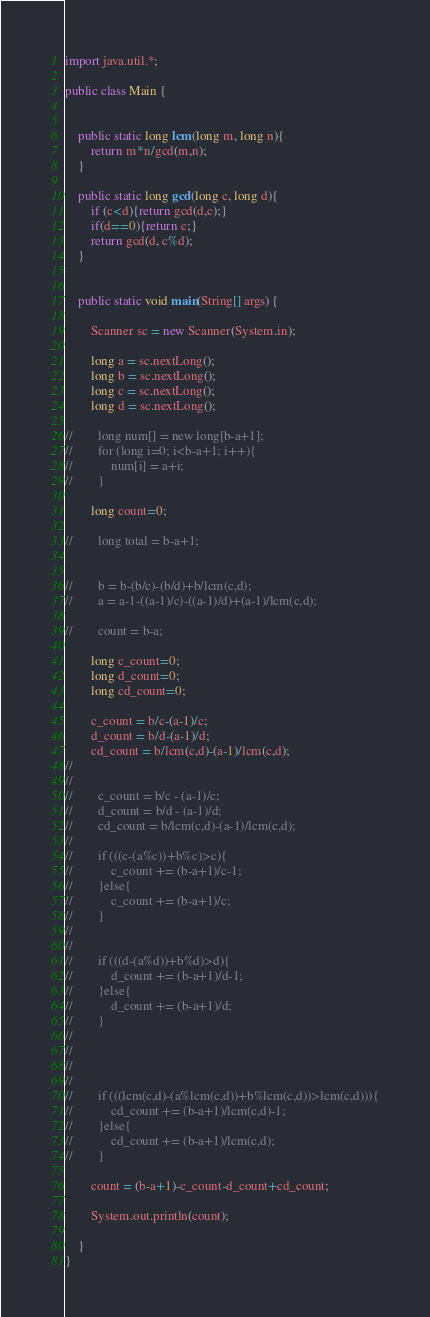<code> <loc_0><loc_0><loc_500><loc_500><_Java_>import java.util.*;

public class Main {


    public static long lcm(long m, long n){
        return m*n/gcd(m,n);
    }

    public static long gcd(long c, long d){
        if (c<d){return gcd(d,c);}
        if(d==0){return c;}
        return gcd(d, c%d);
    }


    public static void main(String[] args) {

        Scanner sc = new Scanner(System.in);

        long a = sc.nextLong();
        long b = sc.nextLong();
        long c = sc.nextLong();
        long d = sc.nextLong();

//        long num[] = new long[b-a+1];
//        for (long i=0; i<b-a+1; i++){
//            num[i] = a+i;
//        }

        long count=0;

//        long total = b-a+1;


//        b = b-(b/c)-(b/d)+b/lcm(c,d);
//        a = a-1-((a-1)/c)-((a-1)/d)+(a-1)/lcm(c,d);

//        count = b-a;

        long c_count=0;
        long d_count=0;
        long cd_count=0;

        c_count = b/c-(a-1)/c;
        d_count = b/d-(a-1)/d;
        cd_count = b/lcm(c,d)-(a-1)/lcm(c,d);
//
//
//        c_count = b/c - (a-1)/c;
//        d_count = b/d - (a-1)/d;
//        cd_count = b/lcm(c,d)-(a-1)/lcm(c,d);
//
//        if (((c-(a%c))+b%c)>c){
//            c_count += (b-a+1)/c-1;
//        }else{
//            c_count += (b-a+1)/c;
//        }
//
//
//        if (((d-(a%d))+b%d)>d){
//            d_count += (b-a+1)/d-1;
//        }else{
//            d_count += (b-a+1)/d;
//        }
//
//
//
//
//        if (((lcm(c,d)-(a%lcm(c,d))+b%lcm(c,d))>lcm(c,d))){
//            cd_count += (b-a+1)/lcm(c,d)-1;
//        }else{
//            cd_count += (b-a+1)/lcm(c,d);
//        }

        count = (b-a+1)-c_count-d_count+cd_count;

        System.out.println(count);

    }
}

</code> 